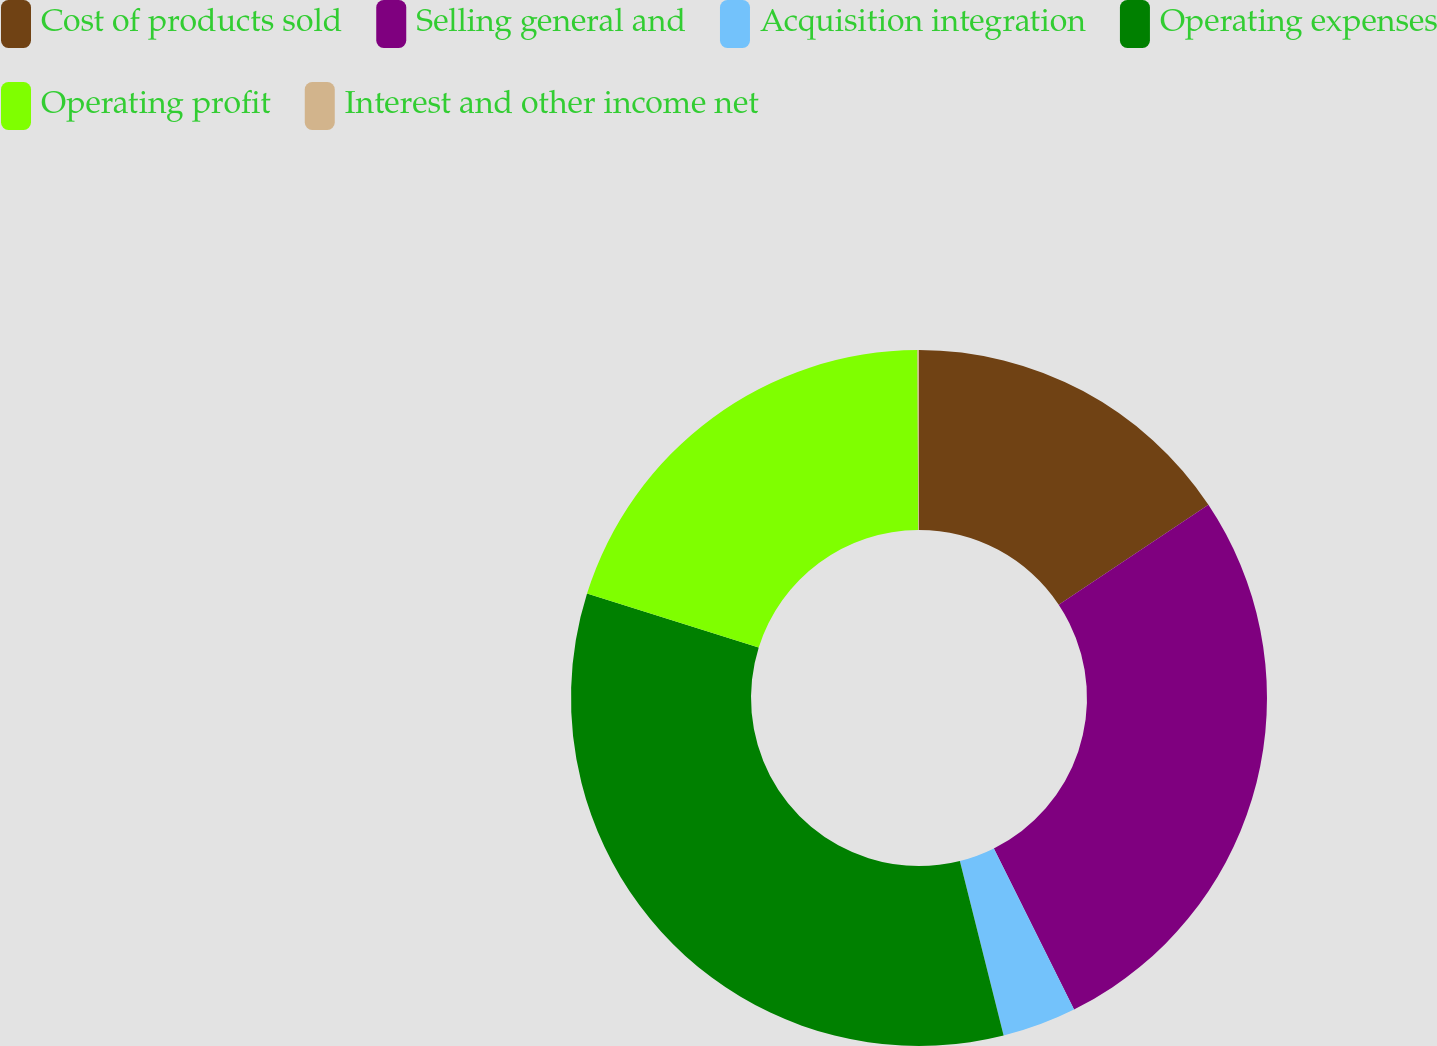<chart> <loc_0><loc_0><loc_500><loc_500><pie_chart><fcel>Cost of products sold<fcel>Selling general and<fcel>Acquisition integration<fcel>Operating expenses<fcel>Operating profit<fcel>Interest and other income net<nl><fcel>15.63%<fcel>27.02%<fcel>3.44%<fcel>33.76%<fcel>20.08%<fcel>0.07%<nl></chart> 